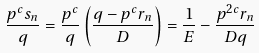Convert formula to latex. <formula><loc_0><loc_0><loc_500><loc_500>\frac { p ^ { c } s _ { n } } { q } = \frac { p ^ { c } } { q } \left ( \frac { q - p ^ { c } r _ { n } } { D } \right ) = \frac { 1 } { E } - \frac { p ^ { 2 c } r _ { n } } { D q }</formula> 